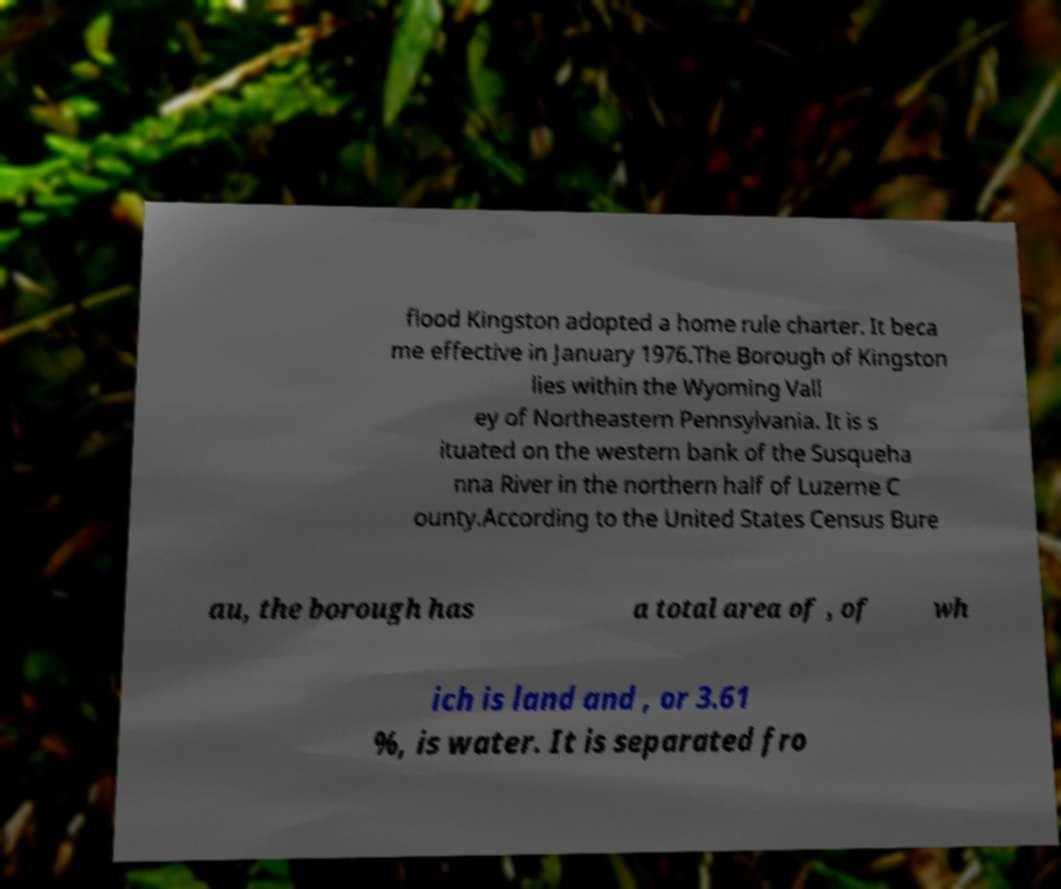There's text embedded in this image that I need extracted. Can you transcribe it verbatim? flood Kingston adopted a home rule charter. It beca me effective in January 1976.The Borough of Kingston lies within the Wyoming Vall ey of Northeastern Pennsylvania. It is s ituated on the western bank of the Susqueha nna River in the northern half of Luzerne C ounty.According to the United States Census Bure au, the borough has a total area of , of wh ich is land and , or 3.61 %, is water. It is separated fro 